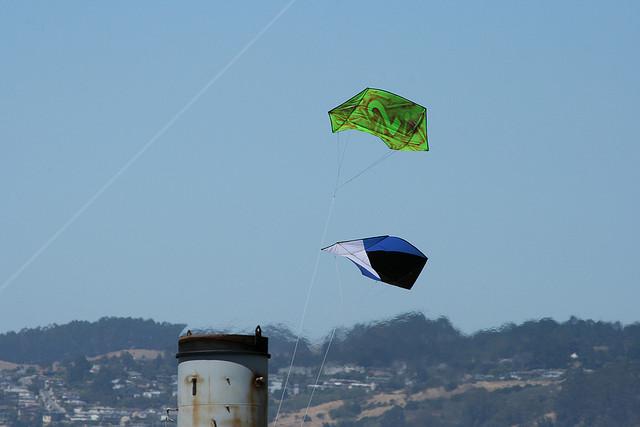How is the weather?
Short answer required. Clear. What number is on the highest kite?
Concise answer only. 2. What color is the sky?
Keep it brief. Blue. 